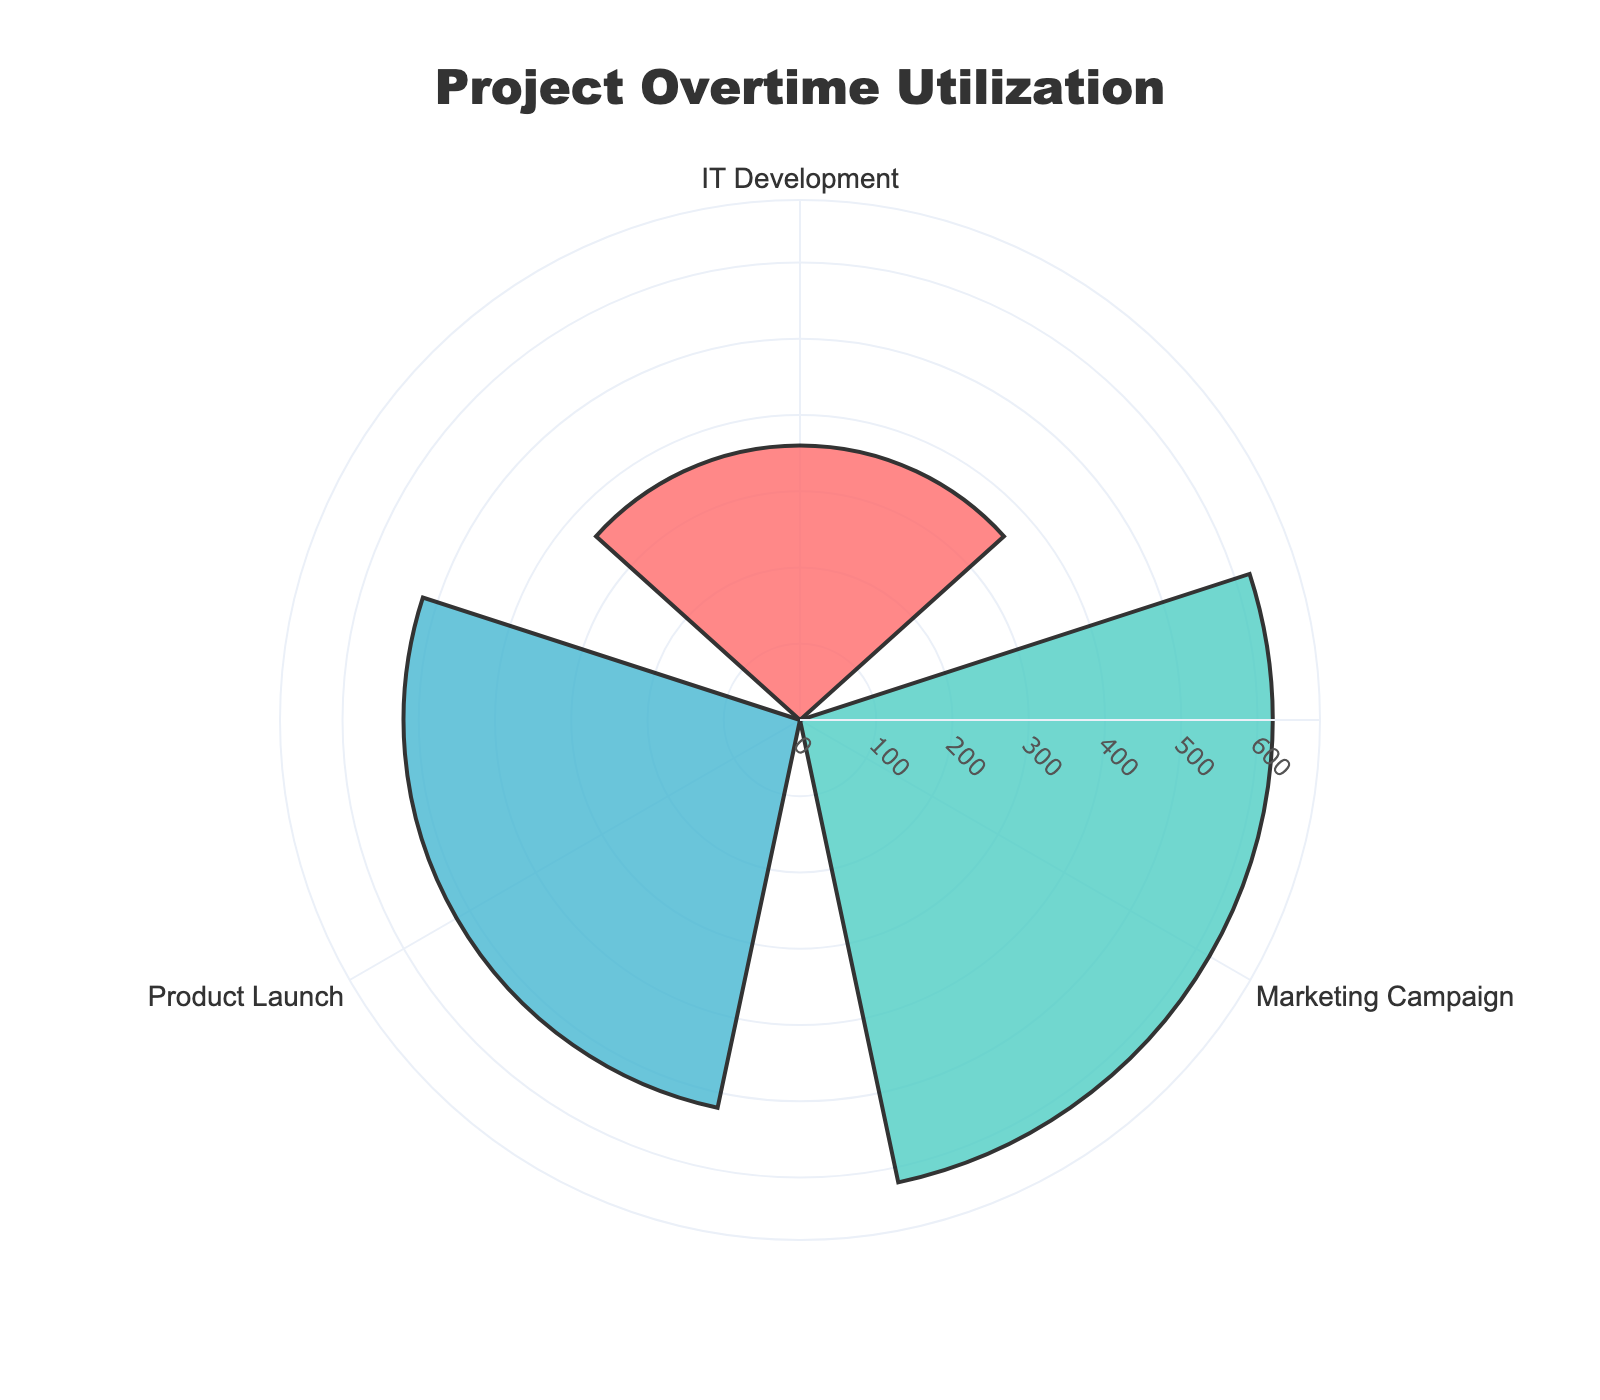What's the title of the chart? The title is usually displayed at the top of the chart. By observing the provided information, the title is "Project Overtime Utilization".
Answer: Project Overtime Utilization How many projects are represented in the chart? The chart shows the number of distinct labels around the circle, each representing a different project. There are three such labels: IT Development, Marketing Campaign, and Product Launch.
Answer: Three Which project has the highest overtime utilization? Look for the project with the longest bar from the center, as this indicates the highest value. The Marketing Campaign's bar extends furthest, indicating the highest overtime utilization.
Answer: Marketing Campaign What are the colors used to represent each project? The legend or the color of the bars in the chart differentiate the projects. IT Development is represented with red, Marketing Campaign with teal, and Product Launch with blue.
Answer: Red, Teal, Blue What is the total overtime utilization for IT Development? The radial value for IT Development can be read from the corresponding bar. The provided data indicates 360 hours for IT Development.
Answer: 360 hours How does the overtime utilization of Product Launch compare to that of IT Development? Compare the lengths of the bars for each project. IT Development has 360 hours, and Product Launch has 520 hours. Product Launch has higher overtime utilization.
Answer: Product Launch has higher overtime utilization What is the total overtime utilization for all projects combined? Sum the overtime hours for each project: IT Development (360) + Marketing Campaign (620) + Product Launch (520) = 1500 hours.
Answer: 1500 hours Which department within Marketing Campaign has the highest overtime utilization? The chart does not show this granularity. We need to refer to the original data: Social Media has the highest overtime at 240 hours.
Answer: Social Media What is the range of the radial axis? The radial axis shows the possible range for values. It starts from 0 and goes up to 700 hours as the chart's maximum.
Answer: 0 to 700 hours By how much does the overtime utilization of Marketing Campaign exceed that of IT Development? Subtract the total overtime of IT Development from that of Marketing Campaign: 620 - 360 = 260 hours.
Answer: 260 hours 